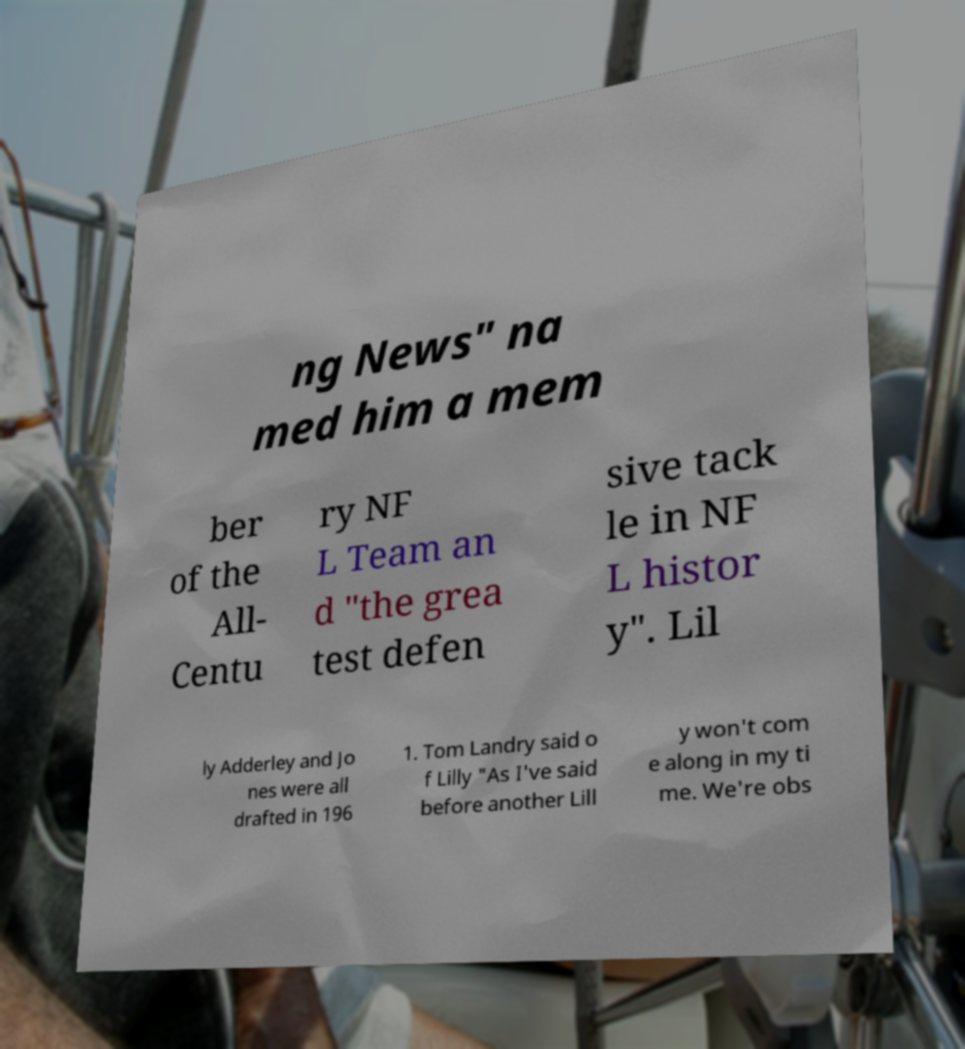Can you read and provide the text displayed in the image?This photo seems to have some interesting text. Can you extract and type it out for me? ng News" na med him a mem ber of the All- Centu ry NF L Team an d "the grea test defen sive tack le in NF L histor y". Lil ly Adderley and Jo nes were all drafted in 196 1. Tom Landry said o f Lilly "As I've said before another Lill y won't com e along in my ti me. We're obs 